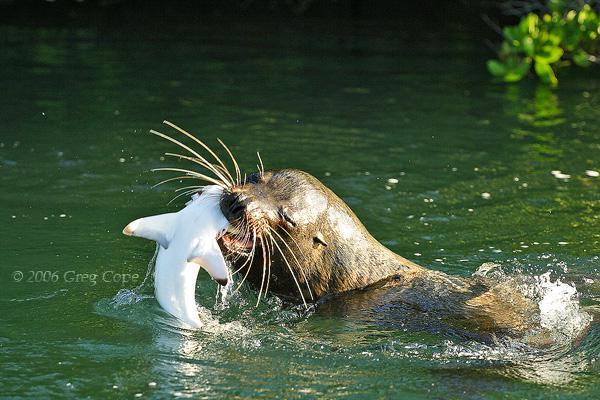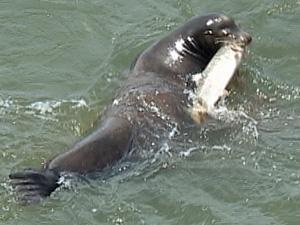The first image is the image on the left, the second image is the image on the right. Assess this claim about the two images: "At least one image shows a sea lion with octopus tentacles in its mouth.". Correct or not? Answer yes or no. No. The first image is the image on the left, the second image is the image on the right. Evaluate the accuracy of this statement regarding the images: "Atleast one image of a seal eating an octopus". Is it true? Answer yes or no. No. 